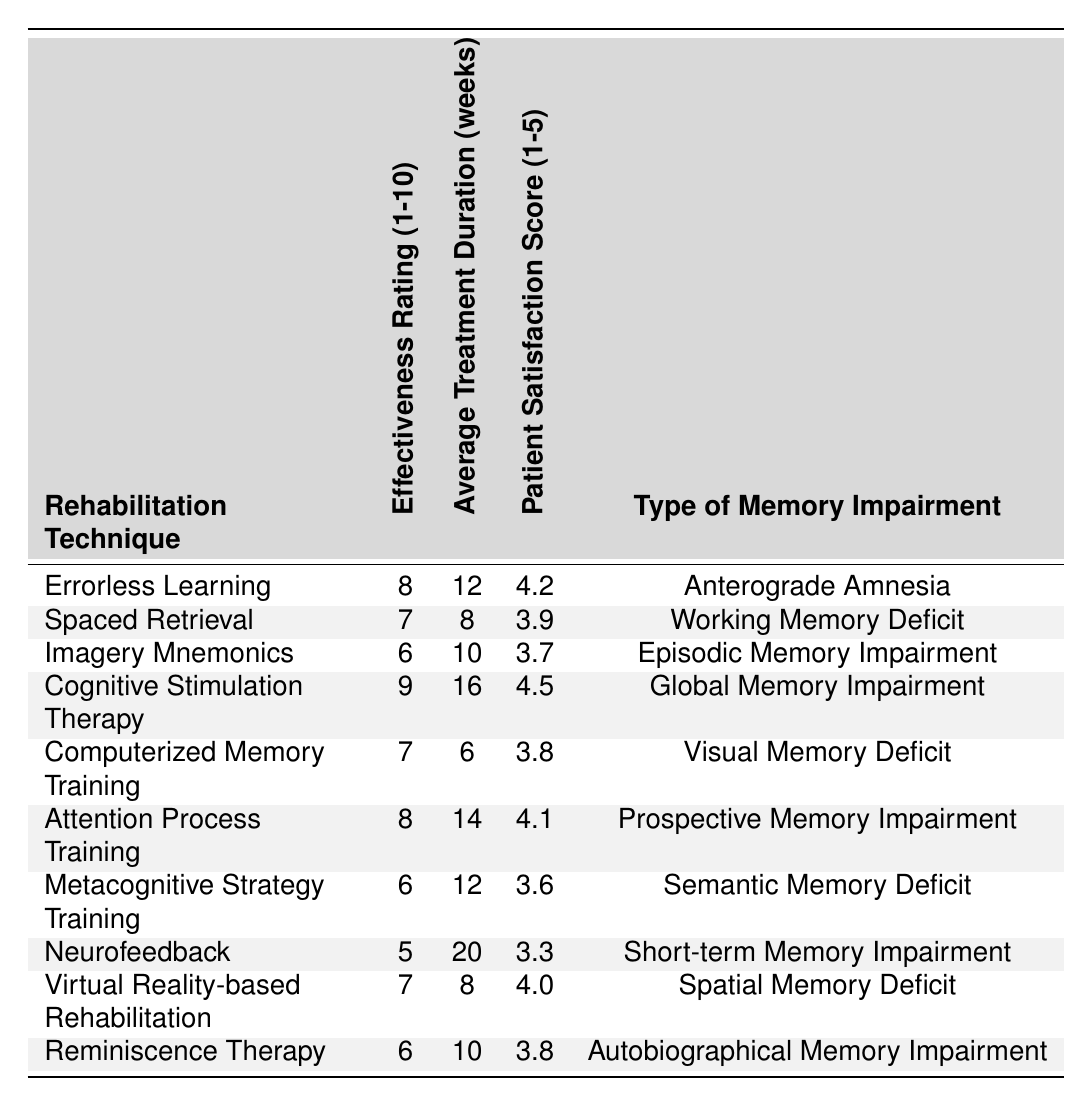What is the effectiveness rating for Cognitive Stimulation Therapy? In the table, the effectiveness rating for Cognitive Stimulation Therapy is explicitly listed as 9.
Answer: 9 Which rehabilitation technique has the highest patient satisfaction score? Looking at the Patient Satisfaction Score column, Cognitive Stimulation Therapy has the highest score of 4.5.
Answer: Cognitive Stimulation Therapy How many weeks does Neurofeedback therapy typically last? The Average Treatment Duration for Neurofeedback, as shown in the table, is 20 weeks.
Answer: 20 weeks What is the effectiveness rating for therapies focused on episodic memory impairment? The table shows that Imagery Mnemonics, which addresses episodic memory impairment, has an effectiveness rating of 6.
Answer: 6 Which cognitive rehabilitation technique has an effectiveness rating of 7? The table lists Computerized Memory Training and Spaced Retrieval, both with effectiveness ratings of 7.
Answer: Computerized Memory Training and Spaced Retrieval What is the average treatment duration for techniques with an effectiveness rating of 8? The techniques with a rating of 8 are Errorless Learning and Attention Process Training; their durations are 12 and 14 weeks, respectively. The average is (12 + 14)/2 = 13 weeks.
Answer: 13 weeks Is the effectiveness rating of Metacognitive Strategy Training higher than Neurofeedback? Metacognitive Strategy Training has a rating of 6, while Neurofeedback has a rating of 5. Since 6 is greater than 5, the statement is true.
Answer: Yes What is the total patient satisfaction score for all techniques focused on memory deficits? Summing the Patient Satisfaction Scores for all techniques gives (4.2 + 3.9 + 3.7 + 4.5 + 3.8 + 4.1 + 3.6 + 3.3 + 4.0 + 3.8) = 39.9.
Answer: 39.9 Which rehabilitation technique has the lowest effectiveness rating? In the table, Neurofeedback has the lowest effectiveness rating at 5.
Answer: Neurofeedback Are the average treatment durations for techniques with effectiveness ratings of 6 less than 12 weeks? The techniques with a rating of 6 are Imagery Mnemonics, Metacognitive Strategy Training, and Reminiscence Therapy, with durations of 10, 12, and 10 weeks, respectively. Since Metacognitive Strategy Training is exactly 12 weeks, not all are less than 12, making the statement false.
Answer: No 